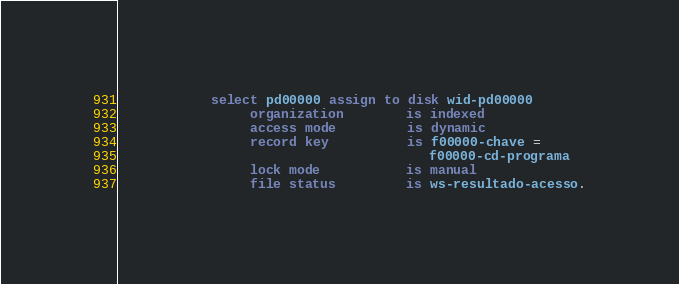Convert code to text. <code><loc_0><loc_0><loc_500><loc_500><_COBOL_>            select pd00000 assign to disk wid-pd00000
                 organization        is indexed
                 access mode         is dynamic
                 record key          is f00000-chave =
                                        f00000-cd-programa
                 lock mode           is manual
                 file status         is ws-resultado-acesso.
</code> 